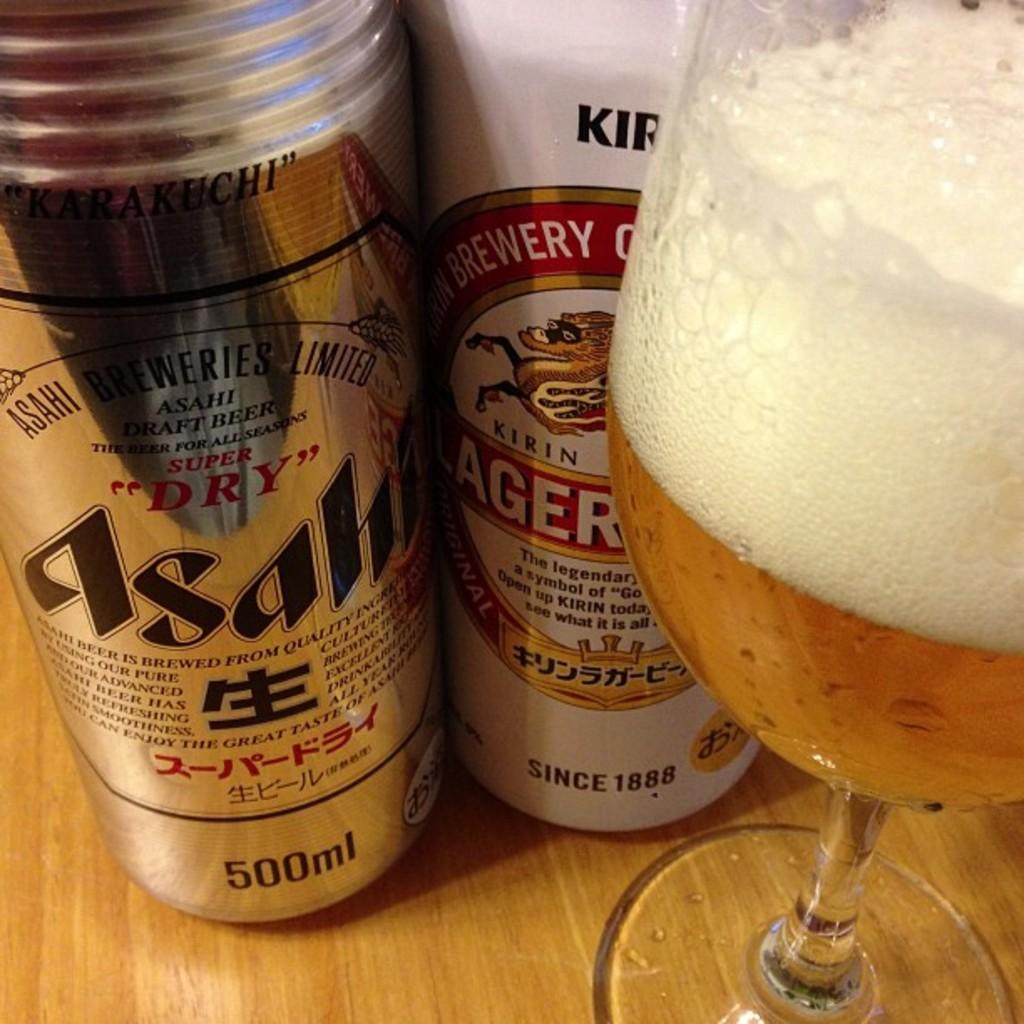How many millileters in the can on the left?
Provide a succinct answer. 500. What is the year "since" on the right can?
Keep it short and to the point. 1888. 